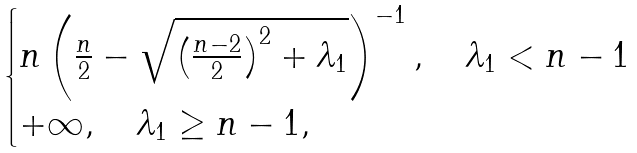<formula> <loc_0><loc_0><loc_500><loc_500>\begin{cases} n \left ( \frac { n } { 2 } - \sqrt { \left ( \frac { n - 2 } { 2 } \right ) ^ { 2 } + \lambda _ { 1 } } \right ) ^ { - 1 } , \quad \lambda _ { 1 } < n - 1 \\ + \infty , \quad \lambda _ { 1 } \geq n - 1 , \end{cases}</formula> 